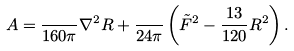<formula> <loc_0><loc_0><loc_500><loc_500>A = \frac { } { 1 6 0 \pi } \nabla ^ { 2 } R + \frac { } { 2 4 \pi } \left ( { \tilde { F } } ^ { 2 } - \frac { 1 3 } { 1 2 0 } R ^ { 2 } \right ) .</formula> 